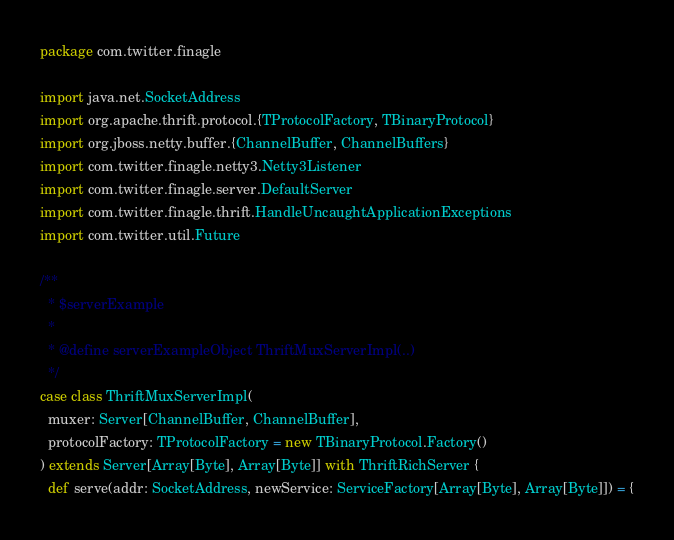<code> <loc_0><loc_0><loc_500><loc_500><_Scala_>package com.twitter.finagle

import java.net.SocketAddress
import org.apache.thrift.protocol.{TProtocolFactory, TBinaryProtocol}
import org.jboss.netty.buffer.{ChannelBuffer, ChannelBuffers}
import com.twitter.finagle.netty3.Netty3Listener
import com.twitter.finagle.server.DefaultServer
import com.twitter.finagle.thrift.HandleUncaughtApplicationExceptions
import com.twitter.util.Future

/**
  * $serverExample
  *
  * @define serverExampleObject ThriftMuxServerImpl(..)
  */
case class ThriftMuxServerImpl(
  muxer: Server[ChannelBuffer, ChannelBuffer],
  protocolFactory: TProtocolFactory = new TBinaryProtocol.Factory()
) extends Server[Array[Byte], Array[Byte]] with ThriftRichServer {
  def serve(addr: SocketAddress, newService: ServiceFactory[Array[Byte], Array[Byte]]) = {</code> 